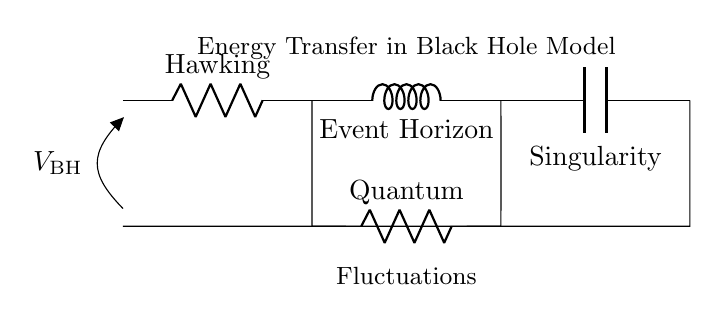What is the resistance value of Hawking? The resistance value of Hawking is denoted as R_h, which represents a component in the circuit.
Answer: R_h What is the role of L_e in the circuit? L_e, or the Event Horizon, is an inductor in this circuit, which participates in energy transfer through magnetic fields.
Answer: Inductor How many resistors are present in the circuit? There are two resistors in the circuit, R_h and R_q, indicating two distinct resistance contributions.
Answer: 2 What component is represented at the singularity? The component represented at the singularity is a capacitor, labeled C_s, indicating a storage of electrical energy.
Answer: C_s Which component has its notation for Quantum? The notation for the Quantum component is R_q, which is located in the lower parallel path of the circuit.
Answer: R_q What does the voltage V_BH signify in this circuit? V_BH represents the black hole voltage, which is the potential difference applied across the circuit from the open node to the ground.
Answer: V_BH Explain the significance of the arrangement of the components in relation to energy transfer. The arrangement of components (R_h, L_e, and C_s in series with R_q in parallel) illustrates how energy is transferred in a black hole model, with resistive losses (R_h and R_q), inductive effects from L_e, and capacitive energy storage at C_s. This setup allows for fluctuations and energy transport, essential in understanding the theoretical dynamics of black holes.
Answer: Energy transfer mechanism 